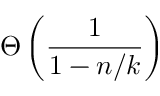Convert formula to latex. <formula><loc_0><loc_0><loc_500><loc_500>\Theta \left ( { \frac { 1 } { 1 - n / k } } \right )</formula> 